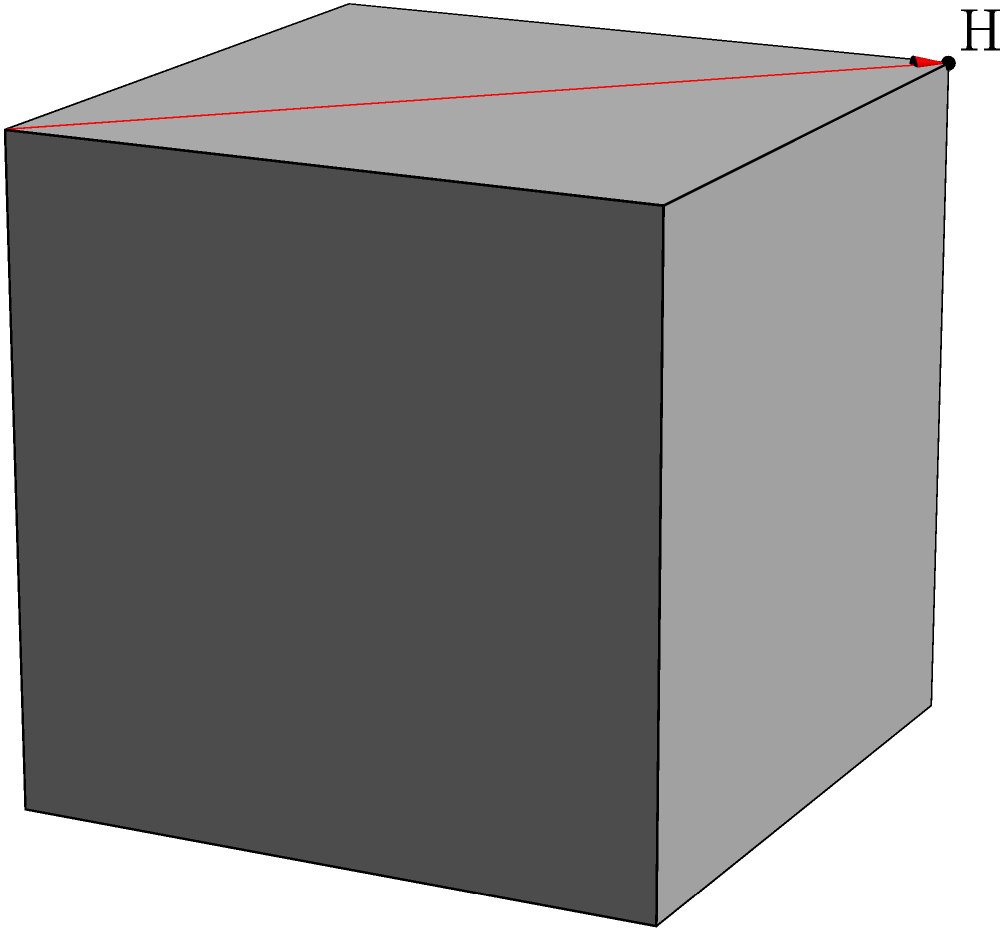As a leader supporting engineering initiatives, you're presented with a problem involving the shortest path between two points on a cube's surface. Consider a unit cube with side length 1. What is the shortest distance between point A (0,0,0) and point H (0,1,1) along the surface of the cube? Express your answer in terms of $\sqrt{2}$. To solve this problem, we need to consider the possible paths and identify the shortest one. Let's approach this step-by-step:

1) First, visualize the cube and the points A and H. Point A is at a corner of the bottom face, and H is at the opposite corner of the top face.

2) The shortest path will be a straight line when the cube is "unfolded" into a plane.

3) There are two main possibilities for the shortest path:
   a) Going across the face ABFE and then up the face EFGH
   b) Going up the face ADHE and then across the face EFGH

4) Both of these paths will have the same length due to symmetry.

5) Let's consider path (a):
   - From A to F is a diagonal of a unit square, which has length $\sqrt{2}$
   - From F to H is a straight line of length 1

6) The total path length is therefore $\sqrt{2} + 1$

7) We can verify this is indeed the shortest path by considering that any other path would involve more "turns" around the cube's edges, which would increase the distance.

8) The question asks for the answer in terms of $\sqrt{2}$. We already have $\sqrt{2}$ in our expression, so we just need to express 1 in terms of $\sqrt{2}$:

   $1 = \frac{\sqrt{2}}{\sqrt{2}} = \frac{\sqrt{2}}{\sqrt{2}} \cdot \frac{\sqrt{2}}{\sqrt{2}} = \frac{2}{\sqrt{2}}$

9) Therefore, the final answer is:

   $\sqrt{2} + 1 = \sqrt{2} + \frac{2}{\sqrt{2}} = \frac{\sqrt{2}\cdot\sqrt{2} + 2}{\sqrt{2}} = \frac{2 + 2}{\sqrt{2}} = \frac{4}{\sqrt{2}}$

This solution demonstrates the importance of spatial reasoning and mathematical problem-solving in engineering contexts.
Answer: $\frac{4}{\sqrt{2}}$ 